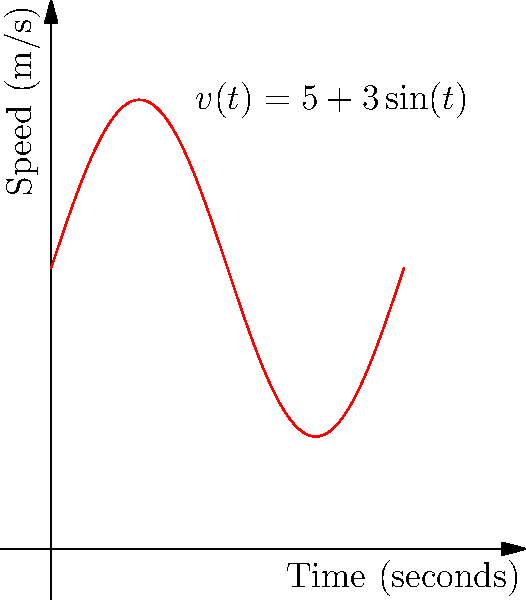During a wrestling match, a wrestler's speed (in meters per second) varies according to the function $v(t) = 5 + 3\sin(t)$, where $t$ is the time in seconds. Calculate the total distance traveled by the wrestler in the first 10 seconds of the match. To solve this problem, we need to integrate the speed function over time to find the total distance traveled. Let's break it down step-by-step:

1) The distance traveled is given by the integral of the speed function:

   $$d = \int_0^{10} v(t) dt$$

2) Substituting our speed function:

   $$d = \int_0^{10} (5 + 3\sin(t)) dt$$

3) We can split this into two integrals:

   $$d = \int_0^{10} 5 dt + \int_0^{10} 3\sin(t) dt$$

4) Solving the first integral:

   $$\int_0^{10} 5 dt = 5t \bigg|_0^{10} = 50$$

5) For the second integral:

   $$\int_0^{10} 3\sin(t) dt = -3\cos(t) \bigg|_0^{10}$$

6) Evaluating the limits:

   $$-3\cos(10) - (-3\cos(0)) = -3\cos(10) + 3$$

7) Adding the results from steps 4 and 6:

   $$d = 50 + (-3\cos(10) + 3)$$

8) Simplifying:

   $$d = 53 - 3\cos(10)$$

Therefore, the total distance traveled by the wrestler in the first 10 seconds is $53 - 3\cos(10)$ meters.
Answer: $53 - 3\cos(10)$ meters 